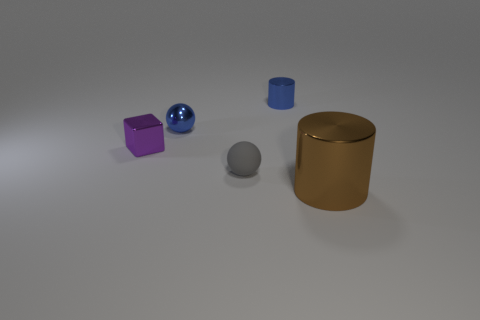Add 4 small blue cylinders. How many objects exist? 9 Subtract all small cylinders. Subtract all tiny balls. How many objects are left? 2 Add 4 small blocks. How many small blocks are left? 5 Add 2 metallic objects. How many metallic objects exist? 6 Subtract all blue cylinders. How many cylinders are left? 1 Subtract 0 purple cylinders. How many objects are left? 5 Subtract all cylinders. How many objects are left? 3 Subtract 2 spheres. How many spheres are left? 0 Subtract all gray spheres. Subtract all yellow blocks. How many spheres are left? 1 Subtract all cyan cubes. How many gray spheres are left? 1 